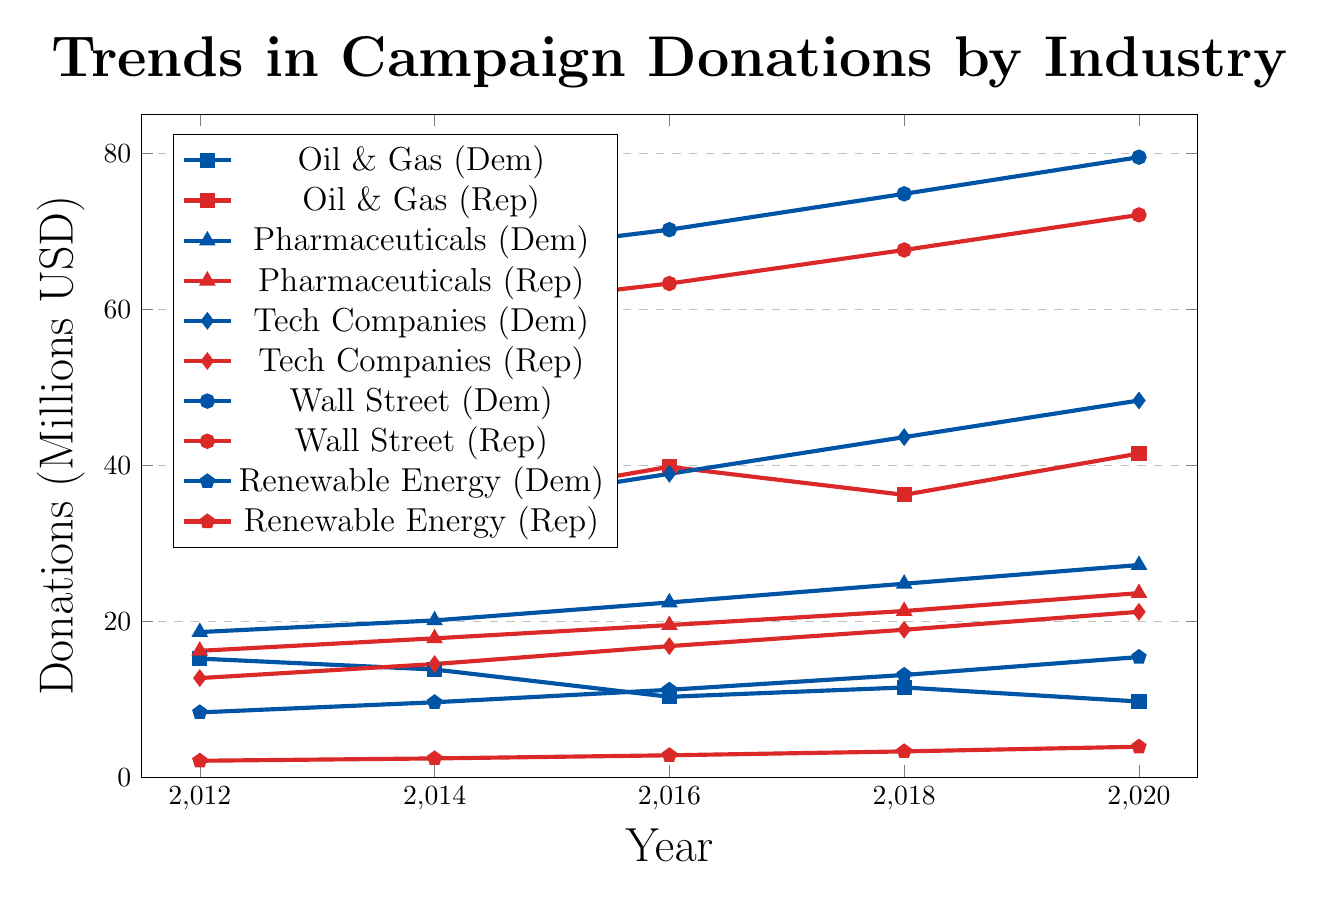What was the total amount donated by the Oil & Gas industry to both parties in 2020? The Democratic Party received 9.7 million USD and the Republican Party received 41.5 million USD from the Oil & Gas industry in 2020. Therefore, the total amount is 9.7 + 41.5 = 51.2 million USD.
Answer: 51.2 million USD In which year did the Republican Party receive more donations from Tech Companies compared to the previous year? The donations to the Republican Party from Tech Companies increased in every election cycle: 12.7 million USD in 2012, 14.5 million USD in 2014, 16.8 million USD in 2016, 18.9 million USD in 2018, and 21.2 million USD in 2020. Hence, each subsequent year between 2012 to 2020 saw an increase compared to the previous year.
Answer: Every year from 2012 to 2020 Which party received more donations from the Pharmaceuticals industry in 2016 and by how much? In 2016, the Democratic Party received 22.4 million USD while the Republican Party received 19.5 million USD from the Pharmaceuticals industry. The difference is 22.4 - 19.5 = 2.9 million USD.
Answer: Democratic Party by 2.9 million USD What trend do you observe in contributions to the Democratic Party from Renewable Energy over the decade? Contributions to the Democratic Party from Renewable Energy have consistently increased over the decade: 8.3 million USD in 2012, 9.6 million USD in 2014, 11.2 million USD in 2016, 13.1 million USD in 2018, and 15.4 million USD in 2020.
Answer: Increasing trend By how much did Wall Street's donations to both parties differ in 2012? In 2012, the Democratic Party received 62.7 million USD and the Republican Party received 56.4 million USD from Wall Street. The difference is 62.7 - 56.4 = 6.3 million USD.
Answer: 6.3 million USD Which industry showed the greatest increase in donations to the Democratic Party from 2012 to 2020? By calculating the differences for each industry:
- Oil & Gas: 9.7 - 15.2 = -5.5 million USD
- Pharmaceuticals: 27.2 - 18.6 = 8.6 million USD
- Tech Companies: 48.3 - 30.5 = 17.8 million USD
- Wall Street: 79.5 - 62.7 = 16.8 million USD
- Renewable Energy: 15.4 - 8.3 = 7.1 million USD
Tech Companies showed the greatest increase with an increase of 17.8 million USD.
Answer: Tech Companies How did Renewable Energy donations to the Republican Party compare to Oil & Gas donations to the same party in 2020? In 2020, the Renewable Energy industry donated 3.9 million USD while the Oil & Gas industry donated 41.5 million USD to the Republican Party. Comparing these, Oil & Gas donations were significantly higher.
Answer: Oil & Gas donations were significantly higher What is the average donation from Wall Street to the Democratic Party between 2012 and 2020? Donations from Wall Street to the Democratic Party were: 62.7, 66.5, 70.2, 74.8, and 79.5 million USD over the years 2012 to 2020. The sum is 353.7 million USD, and the average is 353.7/5 = 70.74 million USD.
Answer: 70.74 million USD 